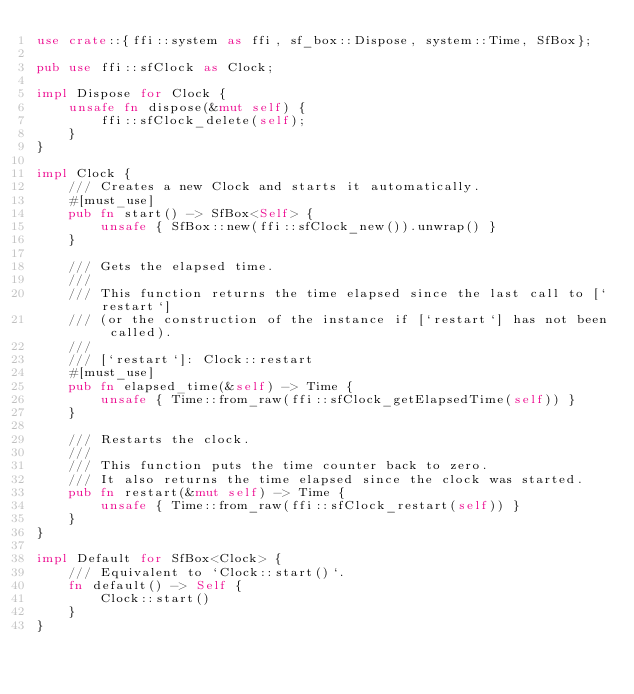Convert code to text. <code><loc_0><loc_0><loc_500><loc_500><_Rust_>use crate::{ffi::system as ffi, sf_box::Dispose, system::Time, SfBox};

pub use ffi::sfClock as Clock;

impl Dispose for Clock {
    unsafe fn dispose(&mut self) {
        ffi::sfClock_delete(self);
    }
}

impl Clock {
    /// Creates a new Clock and starts it automatically.
    #[must_use]
    pub fn start() -> SfBox<Self> {
        unsafe { SfBox::new(ffi::sfClock_new()).unwrap() }
    }

    /// Gets the elapsed time.
    ///
    /// This function returns the time elapsed since the last call to [`restart`]
    /// (or the construction of the instance if [`restart`] has not been called).
    ///
    /// [`restart`]: Clock::restart
    #[must_use]
    pub fn elapsed_time(&self) -> Time {
        unsafe { Time::from_raw(ffi::sfClock_getElapsedTime(self)) }
    }

    /// Restarts the clock.
    ///
    /// This function puts the time counter back to zero.
    /// It also returns the time elapsed since the clock was started.
    pub fn restart(&mut self) -> Time {
        unsafe { Time::from_raw(ffi::sfClock_restart(self)) }
    }
}

impl Default for SfBox<Clock> {
    /// Equivalent to `Clock::start()`.
    fn default() -> Self {
        Clock::start()
    }
}
</code> 